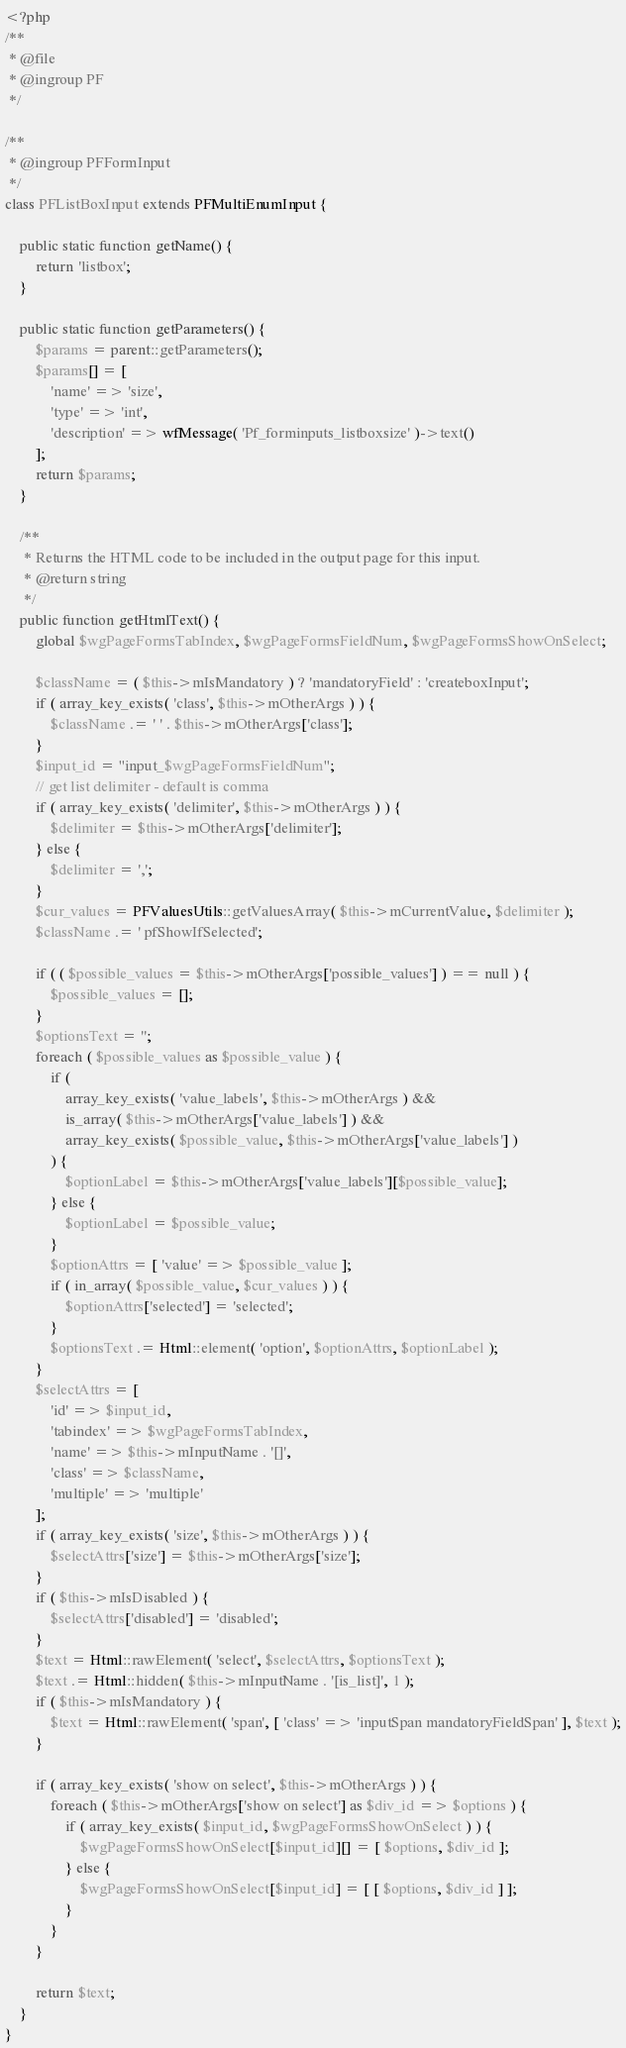<code> <loc_0><loc_0><loc_500><loc_500><_PHP_><?php
/**
 * @file
 * @ingroup PF
 */

/**
 * @ingroup PFFormInput
 */
class PFListBoxInput extends PFMultiEnumInput {

	public static function getName() {
		return 'listbox';
	}

	public static function getParameters() {
		$params = parent::getParameters();
		$params[] = [
			'name' => 'size',
			'type' => 'int',
			'description' => wfMessage( 'Pf_forminputs_listboxsize' )->text()
		];
		return $params;
	}

	/**
	 * Returns the HTML code to be included in the output page for this input.
	 * @return string
	 */
	public function getHtmlText() {
		global $wgPageFormsTabIndex, $wgPageFormsFieldNum, $wgPageFormsShowOnSelect;

		$className = ( $this->mIsMandatory ) ? 'mandatoryField' : 'createboxInput';
		if ( array_key_exists( 'class', $this->mOtherArgs ) ) {
			$className .= ' ' . $this->mOtherArgs['class'];
		}
		$input_id = "input_$wgPageFormsFieldNum";
		// get list delimiter - default is comma
		if ( array_key_exists( 'delimiter', $this->mOtherArgs ) ) {
			$delimiter = $this->mOtherArgs['delimiter'];
		} else {
			$delimiter = ',';
		}
		$cur_values = PFValuesUtils::getValuesArray( $this->mCurrentValue, $delimiter );
		$className .= ' pfShowIfSelected';

		if ( ( $possible_values = $this->mOtherArgs['possible_values'] ) == null ) {
			$possible_values = [];
		}
		$optionsText = '';
		foreach ( $possible_values as $possible_value ) {
			if (
				array_key_exists( 'value_labels', $this->mOtherArgs ) &&
				is_array( $this->mOtherArgs['value_labels'] ) &&
				array_key_exists( $possible_value, $this->mOtherArgs['value_labels'] )
			) {
				$optionLabel = $this->mOtherArgs['value_labels'][$possible_value];
			} else {
				$optionLabel = $possible_value;
			}
			$optionAttrs = [ 'value' => $possible_value ];
			if ( in_array( $possible_value, $cur_values ) ) {
				$optionAttrs['selected'] = 'selected';
			}
			$optionsText .= Html::element( 'option', $optionAttrs, $optionLabel );
		}
		$selectAttrs = [
			'id' => $input_id,
			'tabindex' => $wgPageFormsTabIndex,
			'name' => $this->mInputName . '[]',
			'class' => $className,
			'multiple' => 'multiple'
		];
		if ( array_key_exists( 'size', $this->mOtherArgs ) ) {
			$selectAttrs['size'] = $this->mOtherArgs['size'];
		}
		if ( $this->mIsDisabled ) {
			$selectAttrs['disabled'] = 'disabled';
		}
		$text = Html::rawElement( 'select', $selectAttrs, $optionsText );
		$text .= Html::hidden( $this->mInputName . '[is_list]', 1 );
		if ( $this->mIsMandatory ) {
			$text = Html::rawElement( 'span', [ 'class' => 'inputSpan mandatoryFieldSpan' ], $text );
		}

		if ( array_key_exists( 'show on select', $this->mOtherArgs ) ) {
			foreach ( $this->mOtherArgs['show on select'] as $div_id => $options ) {
				if ( array_key_exists( $input_id, $wgPageFormsShowOnSelect ) ) {
					$wgPageFormsShowOnSelect[$input_id][] = [ $options, $div_id ];
				} else {
					$wgPageFormsShowOnSelect[$input_id] = [ [ $options, $div_id ] ];
				}
			}
		}

		return $text;
	}
}
</code> 